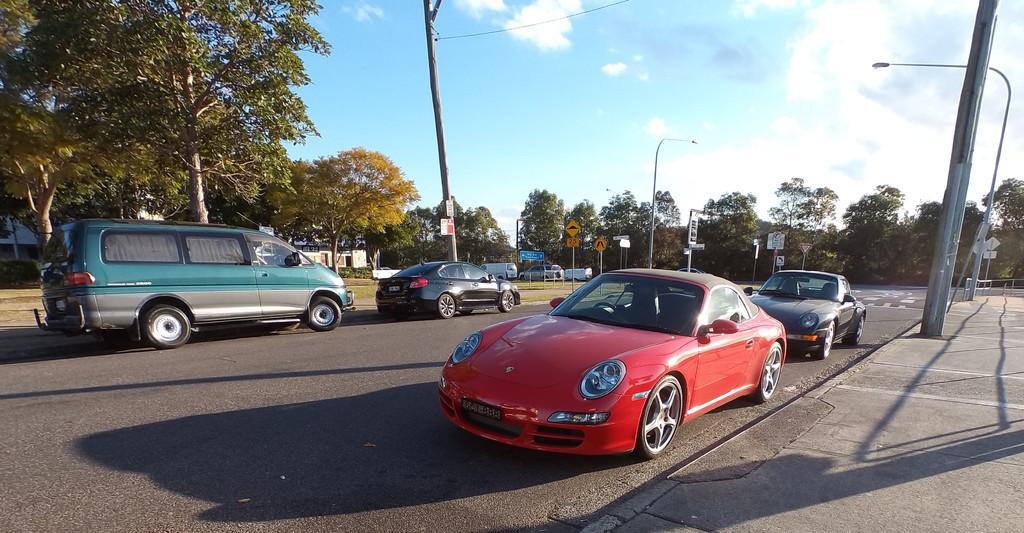Describe this image in one or two sentences. In the image we can see there are many vehicles on the road. There is a road, footpath, electric pole, light pole, trees, grass, buildings, board and a cloudy sky. These are the headlights and number plate of the vehicle. 